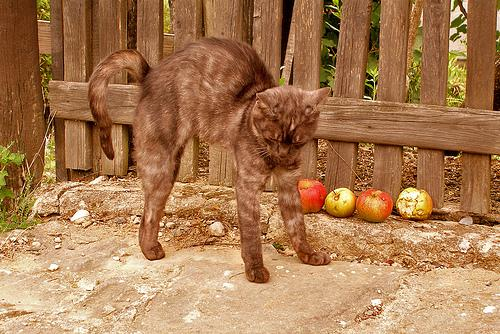Question: what animal is this?
Choices:
A. Dog.
B. Cat.
C. Fish.
D. Hamster.
Answer with the letter. Answer: B Question: who is there?
Choices:
A. No one.
B. 1 person.
C. 2 people.
D. 3 people.
Answer with the letter. Answer: A Question: what type of scene is this?
Choices:
A. Indoor.
B. Both.
C. Outdoor.
D. Neither.
Answer with the letter. Answer: C Question: when was this?
Choices:
A. Dawn.
B. Daytime.
C. Midnight.
D. Twilight.
Answer with the letter. Answer: B 